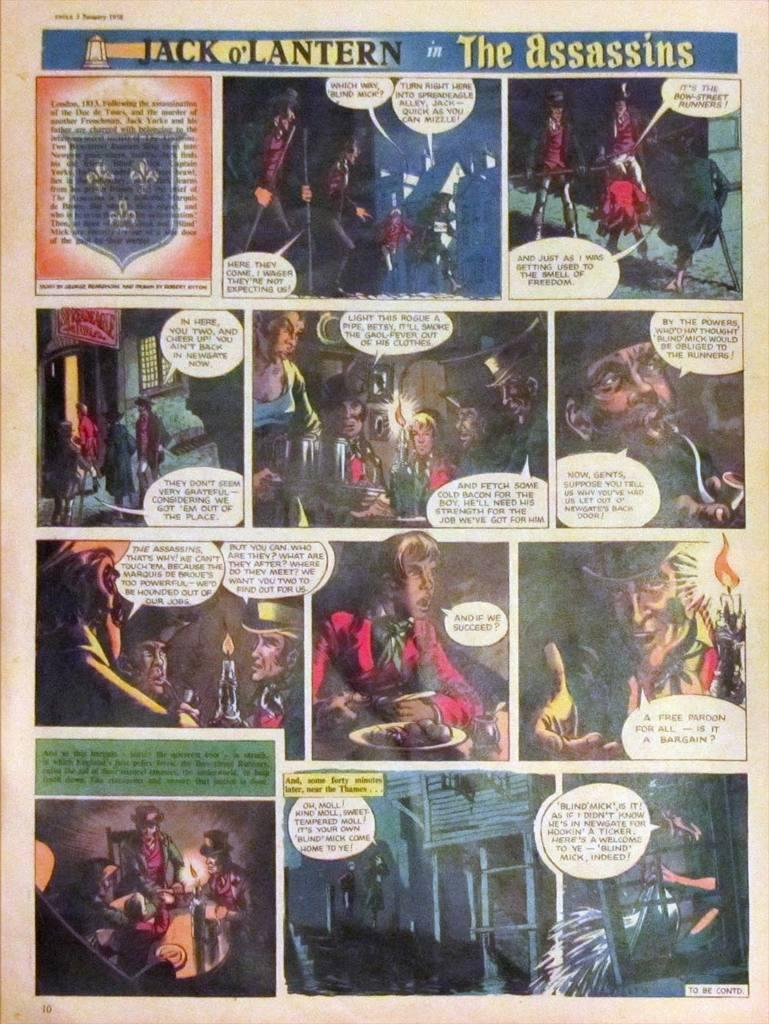<image>
Share a concise interpretation of the image provided. A comic strip is titled Jack o' Lantern. 